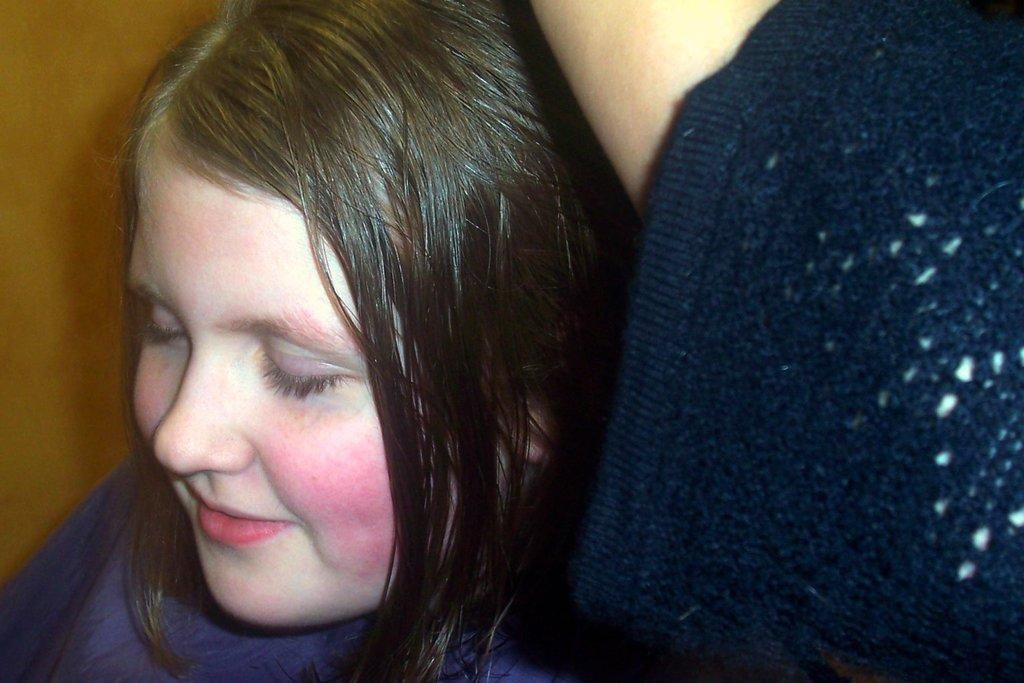Who is the main subject in the image? There is a girl in the image. What is the girl doing in the image? The girl is smiling and closing her eyes. What can be seen behind the girl in the image? There is a wall behind the girl. What does the stranger say to the girl in the image? There is no stranger present in the image, so it is not possible to determine what they might say to the girl. 